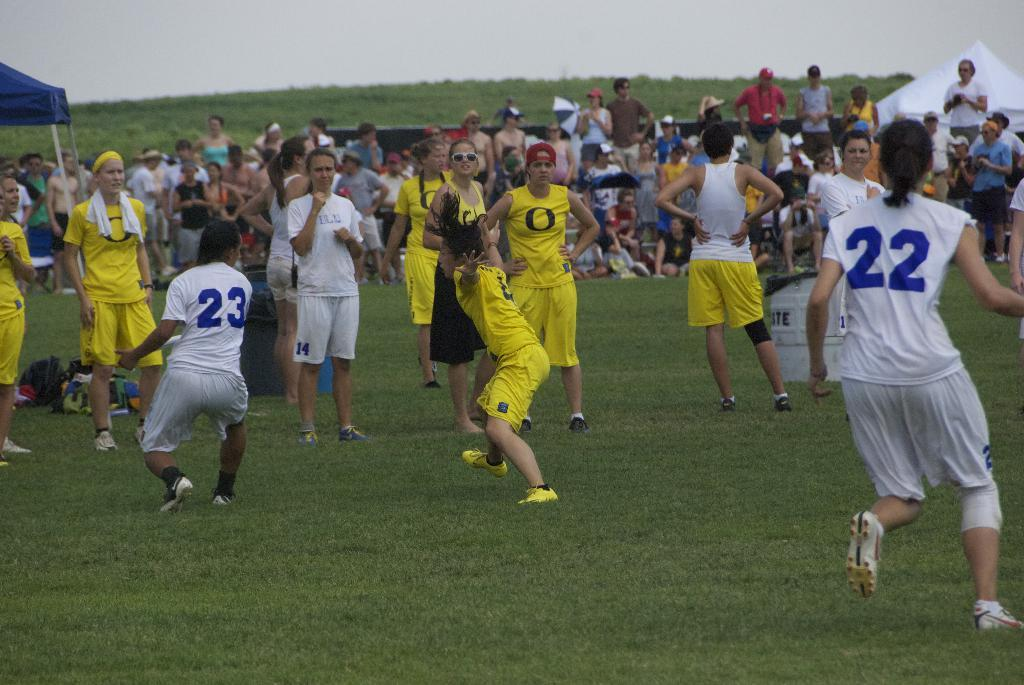<image>
Offer a succinct explanation of the picture presented. A game is being played players 22 and 23 are on the field. 